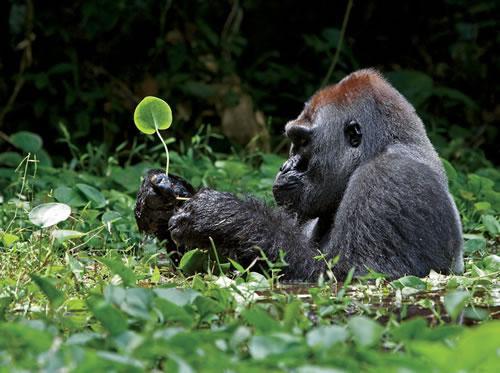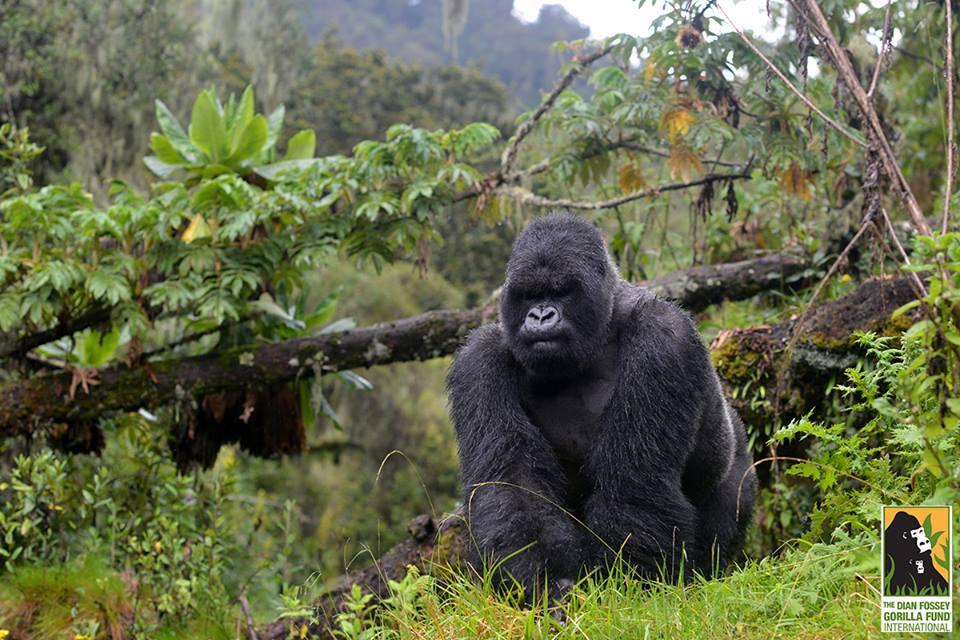The first image is the image on the left, the second image is the image on the right. For the images shown, is this caption "The left image contains exactly one gorilla." true? Answer yes or no. Yes. The first image is the image on the left, the second image is the image on the right. Given the left and right images, does the statement "There are two gorillas in the pair of images." hold true? Answer yes or no. Yes. 